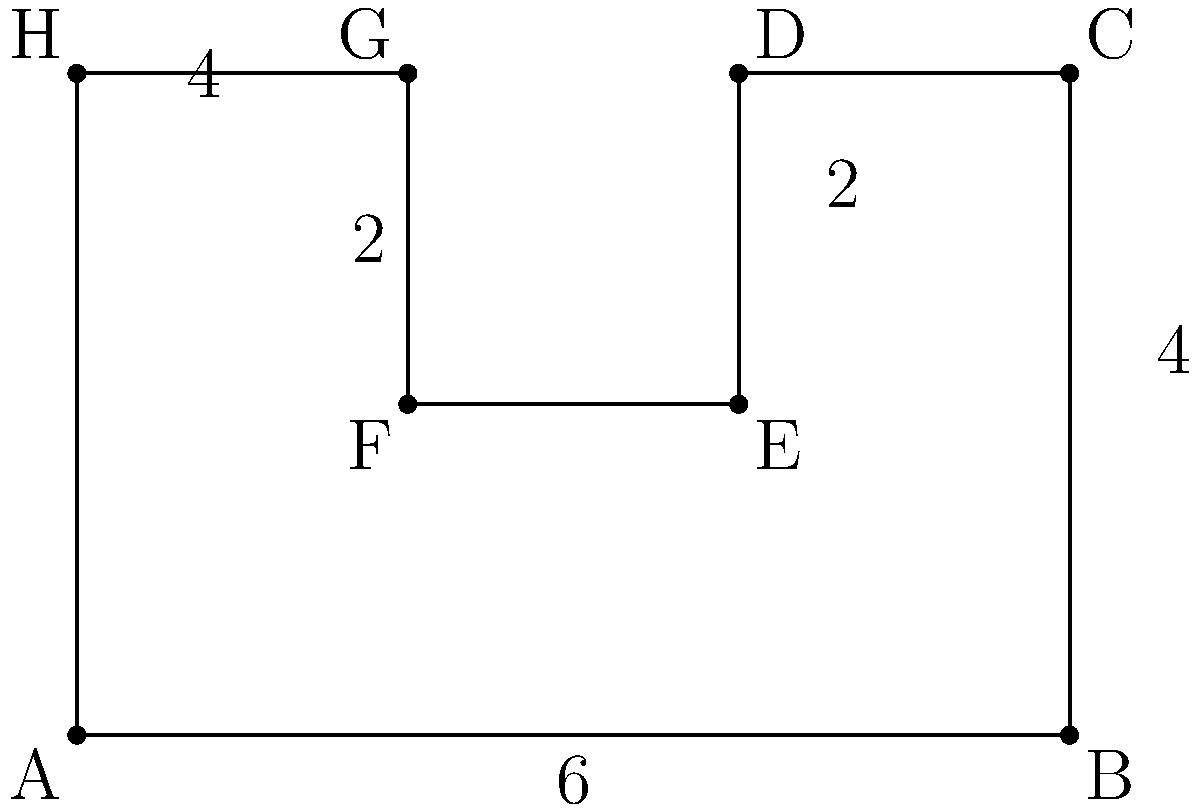A client has requested a custom banner with an irregular shape for their event. The shape is represented in the diagram above, with measurements in feet. Calculate the total area of the banner to determine the amount of material needed for production. To calculate the area of this irregular shape, we can break it down into rectangles:

1. Main rectangle (ABCH):
   Area = $6 \text{ ft} \times 4 \text{ ft} = 24 \text{ sq ft}$

2. Subtract the area of the cut-out rectangle (DEFG):
   Cut-out area = $2 \text{ ft} \times 2 \text{ ft} = 4 \text{ sq ft}$

3. Calculate the total area:
   Total area = Main rectangle area - Cut-out area
   Total area = $24 \text{ sq ft} - 4 \text{ sq ft} = 20 \text{ sq ft}$

Therefore, the total area of the banner is 20 square feet.
Answer: 20 sq ft 